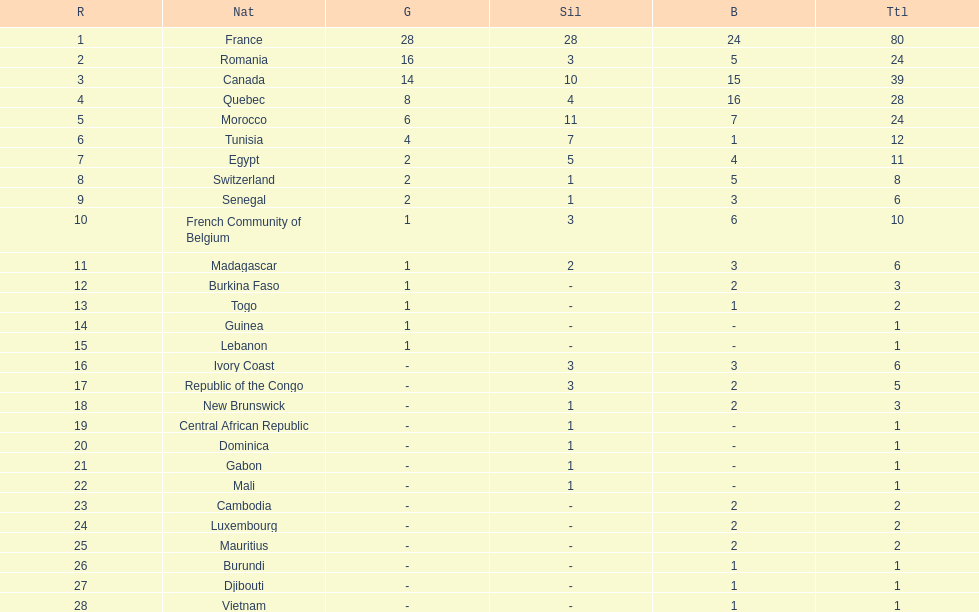What is the difference between france's and egypt's silver medals? 23. 